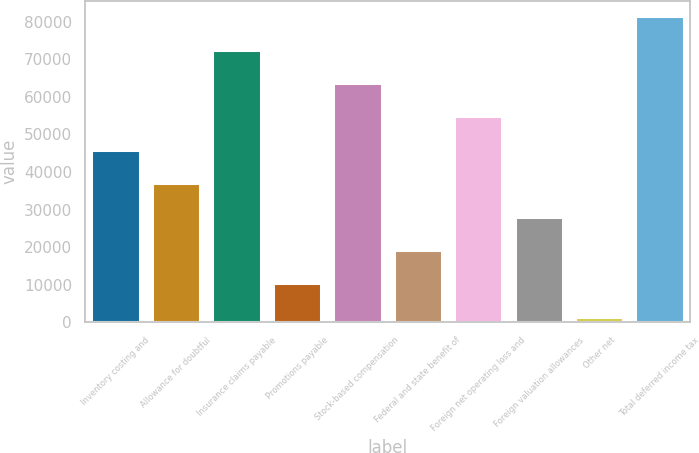Convert chart. <chart><loc_0><loc_0><loc_500><loc_500><bar_chart><fcel>Inventory costing and<fcel>Allowance for doubtful<fcel>Insurance claims payable<fcel>Promotions payable<fcel>Stock-based compensation<fcel>Federal and state benefit of<fcel>Foreign net operating loss and<fcel>Foreign valuation allowances<fcel>Other net<fcel>Total deferred income tax<nl><fcel>45911<fcel>37037<fcel>72533<fcel>10415<fcel>63659<fcel>19289<fcel>54785<fcel>28163<fcel>1541<fcel>81407<nl></chart> 